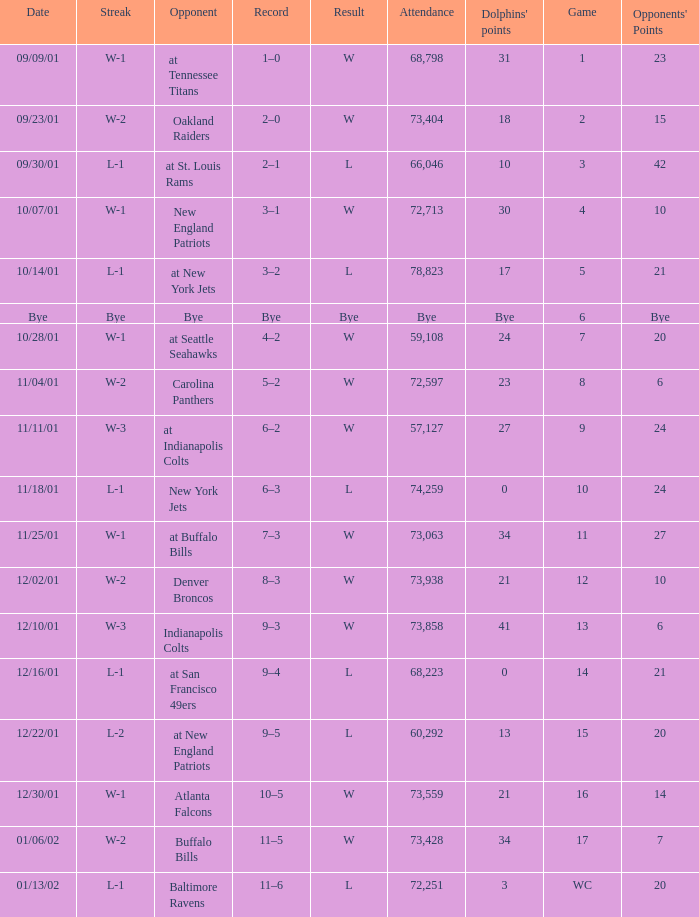What is the streak for game 16 when the Dolphins had 21 points? W-1. 